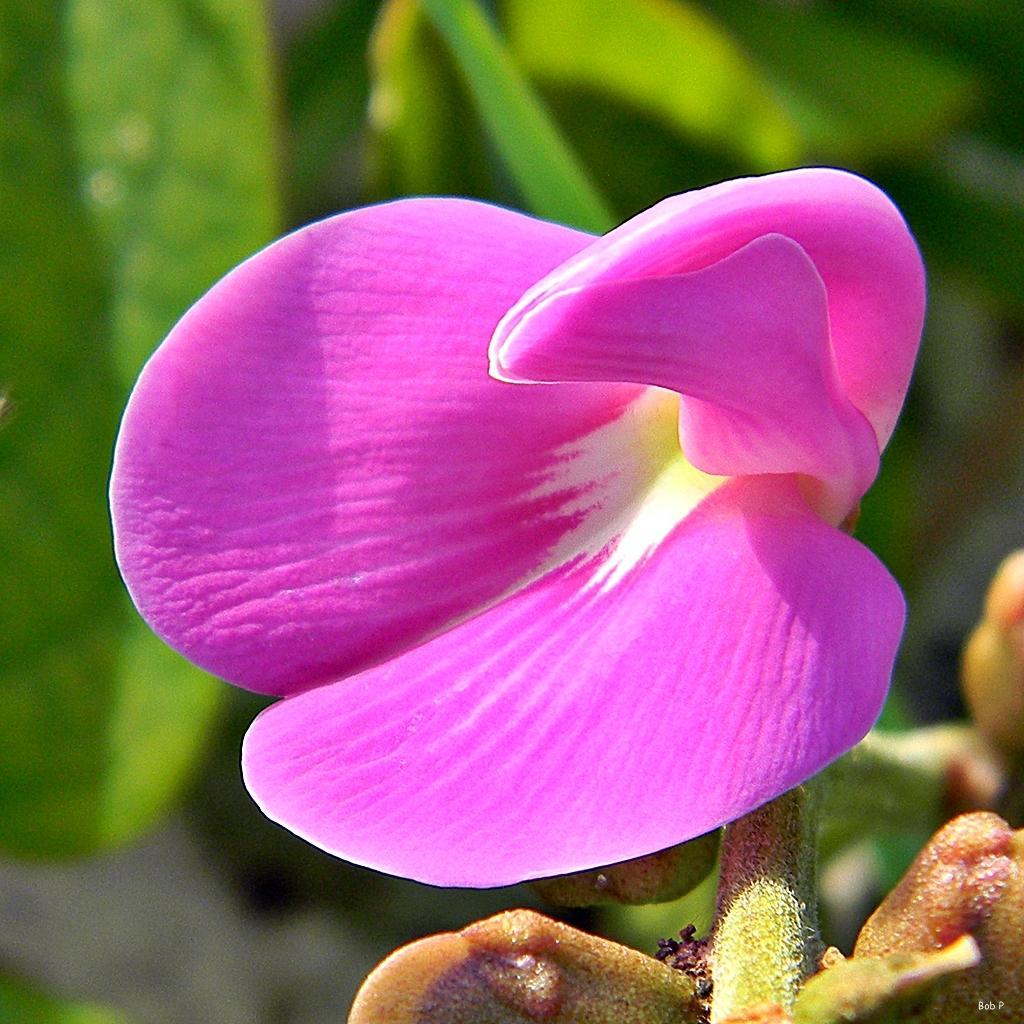How would you summarize this image in a sentence or two? In this image there is a pink flower in the middle. In the background there are green leaves. 